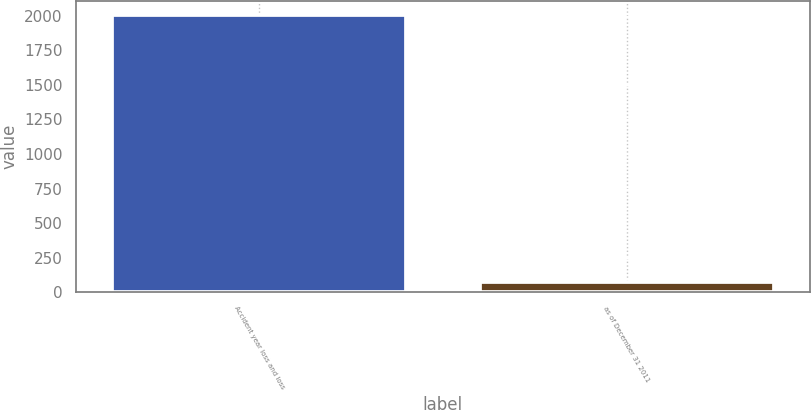<chart> <loc_0><loc_0><loc_500><loc_500><bar_chart><fcel>Accident year loss and loss<fcel>as of December 31 2011<nl><fcel>2010<fcel>71.6<nl></chart> 